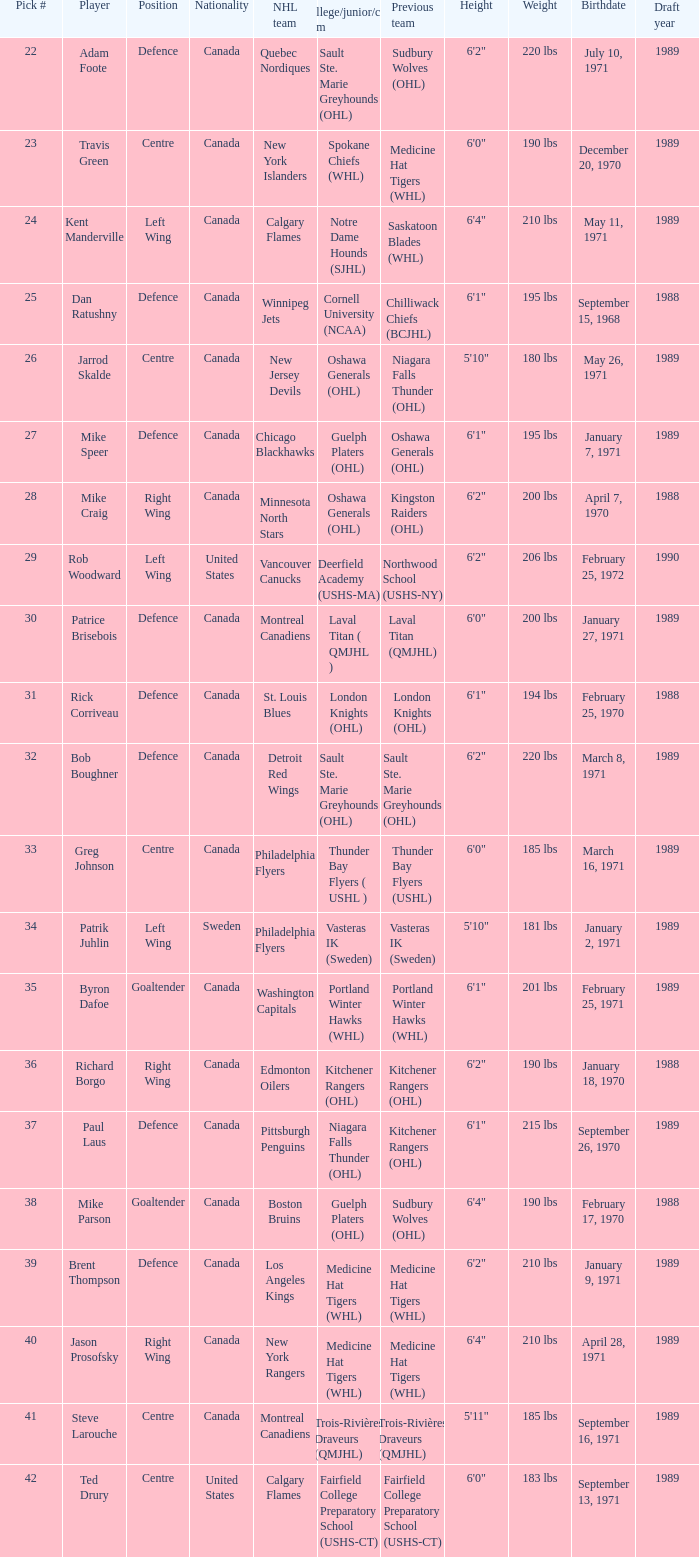How many draft picks is player byron dafoe? 1.0. 